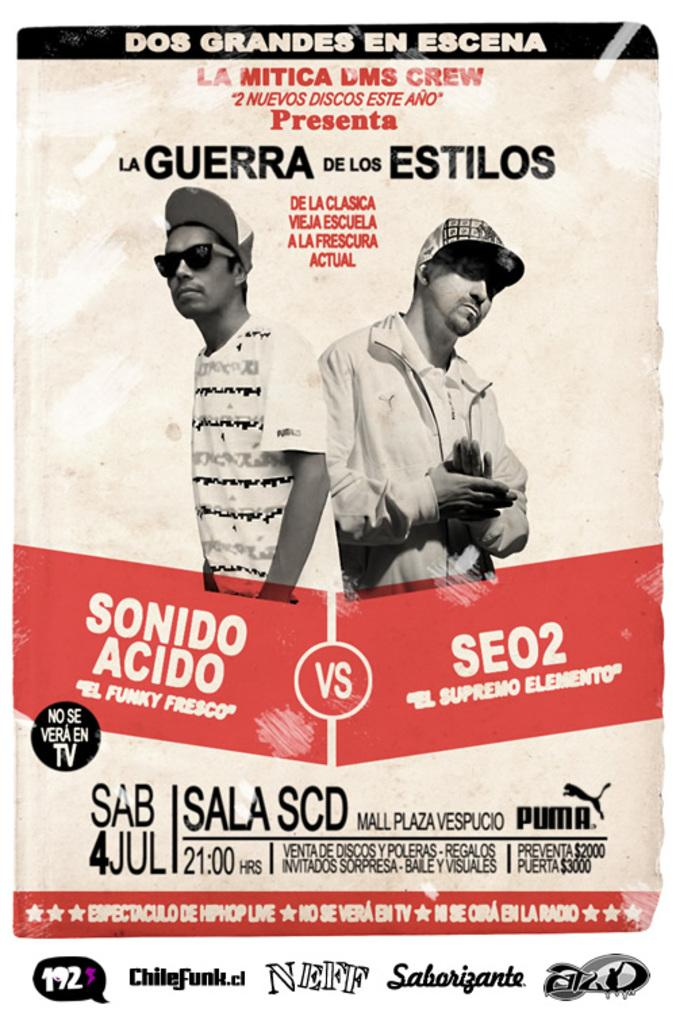What type of visual content is depicted in the image? The image appears to be a poster. Can you describe the main subjects in the image? There are two persons in the middle of the image. How was the image manipulated or altered? The image has been edited. What additional information can be found on the image? There is text or writing on the image. What type of root can be seen growing in the image? There is no root present in the image; it is a poster featuring two persons. How many stoves are visible in the image? There are no stoves present in the image. 